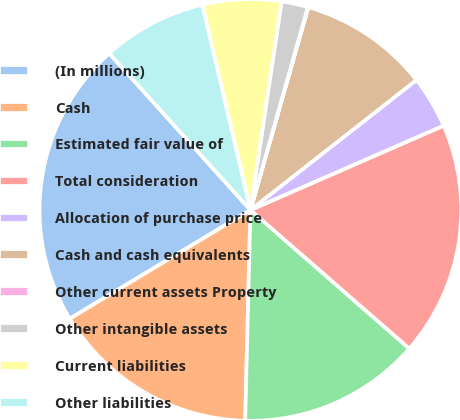<chart> <loc_0><loc_0><loc_500><loc_500><pie_chart><fcel>(In millions)<fcel>Cash<fcel>Estimated fair value of<fcel>Total consideration<fcel>Allocation of purchase price<fcel>Cash and cash equivalents<fcel>Other current assets Property<fcel>Other intangible assets<fcel>Current liabilities<fcel>Other liabilities<nl><fcel>21.95%<fcel>15.98%<fcel>13.98%<fcel>17.97%<fcel>4.02%<fcel>10.0%<fcel>0.04%<fcel>2.03%<fcel>6.02%<fcel>8.01%<nl></chart> 